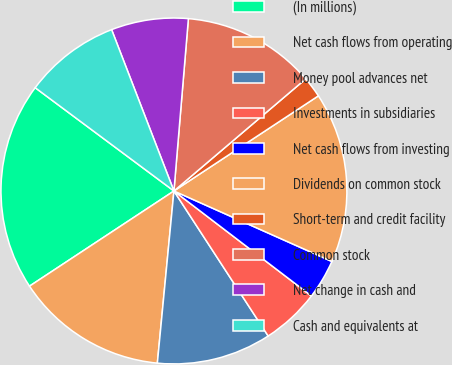Convert chart to OTSL. <chart><loc_0><loc_0><loc_500><loc_500><pie_chart><fcel>(In millions)<fcel>Net cash flows from operating<fcel>Money pool advances net<fcel>Investments in subsidiaries<fcel>Net cash flows from investing<fcel>Dividends on common stock<fcel>Short-term and credit facility<fcel>Common stock<fcel>Net change in cash and<fcel>Cash and equivalents at<nl><fcel>19.46%<fcel>14.2%<fcel>10.7%<fcel>5.45%<fcel>3.7%<fcel>15.95%<fcel>1.95%<fcel>12.45%<fcel>7.2%<fcel>8.95%<nl></chart> 